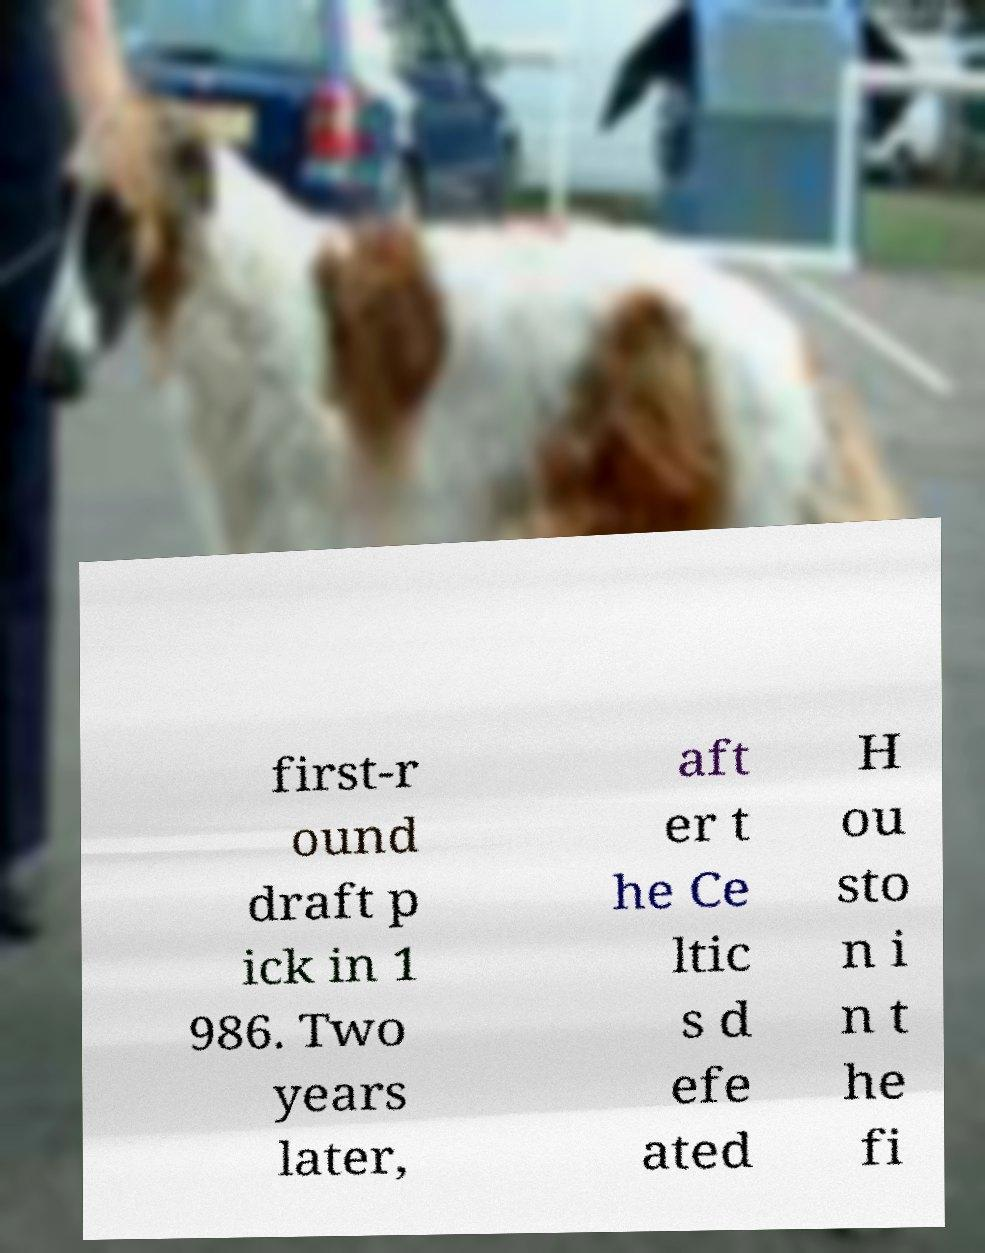Can you accurately transcribe the text from the provided image for me? first-r ound draft p ick in 1 986. Two years later, aft er t he Ce ltic s d efe ated H ou sto n i n t he fi 